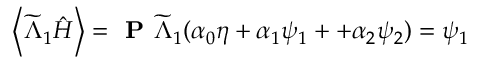<formula> <loc_0><loc_0><loc_500><loc_500>\left \langle \widetilde { \Lambda } _ { 1 } \hat { H } \right \rangle = P \widetilde { \Lambda } _ { 1 } ( \alpha _ { 0 } \eta + \alpha _ { 1 } \psi _ { 1 } + + \alpha _ { 2 } \psi _ { 2 } ) = \psi _ { 1 }</formula> 